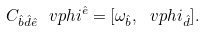<formula> <loc_0><loc_0><loc_500><loc_500>C _ { \hat { b } \hat { d } \hat { e } } \ v p h i ^ { \hat { e } } = [ \omega _ { \hat { b } } , \ v p h i _ { \hat { d } } ] .</formula> 